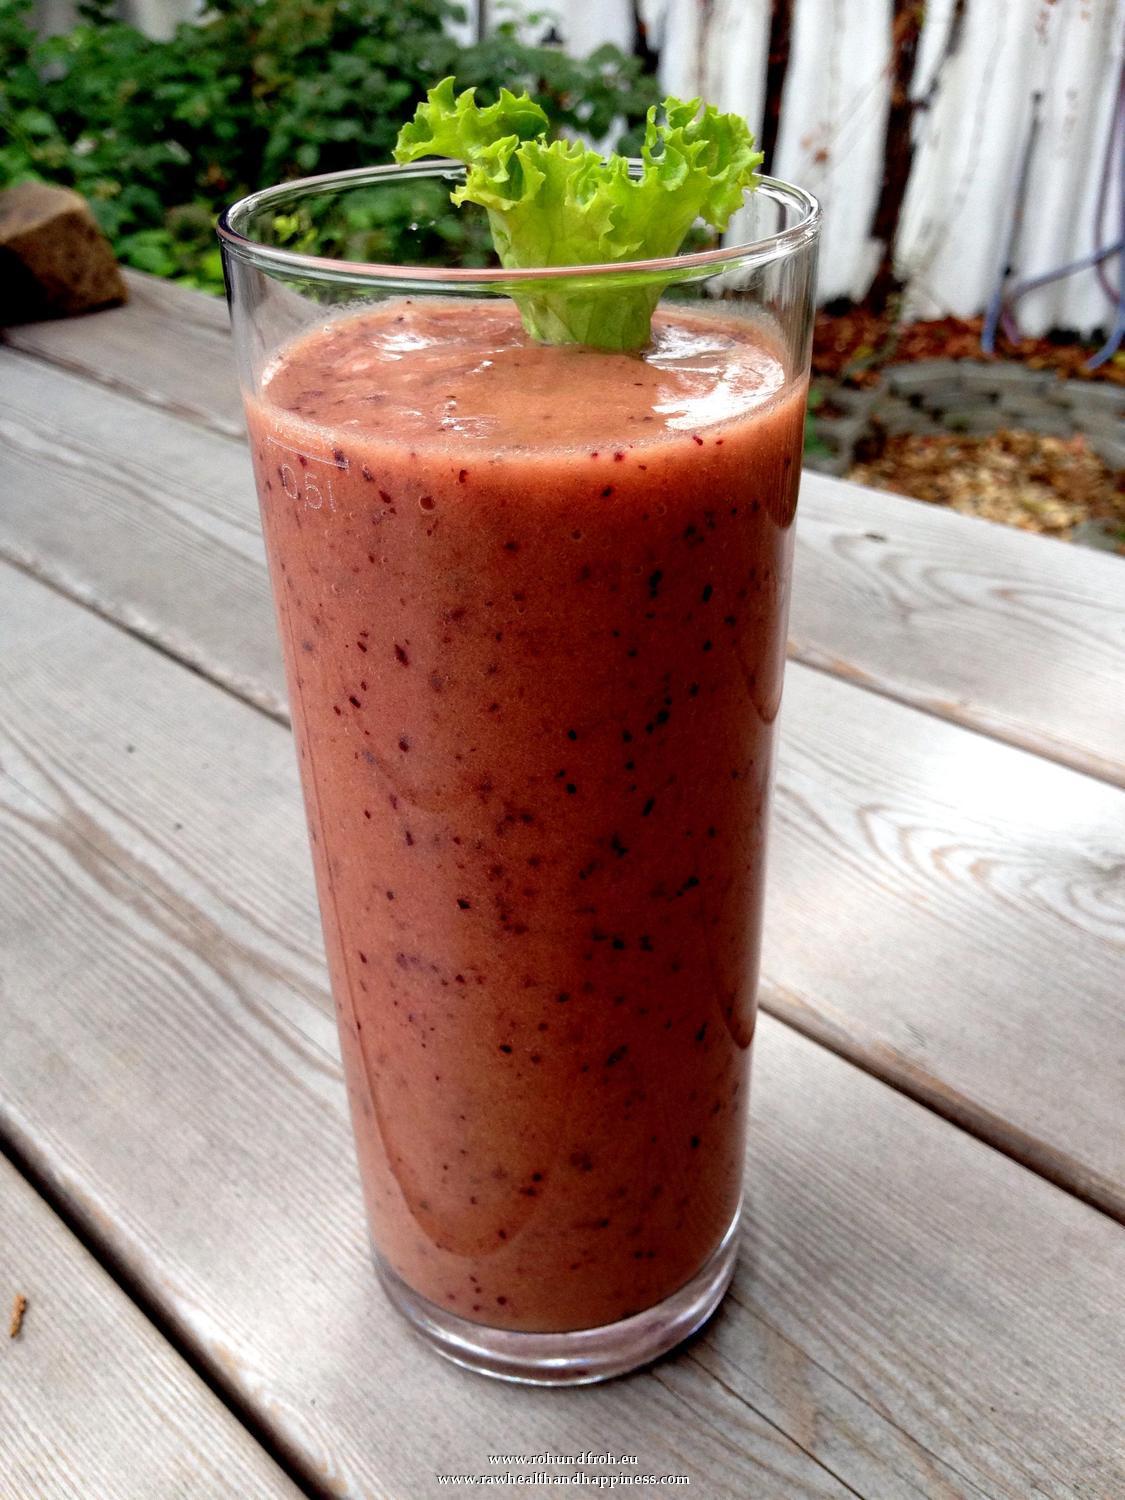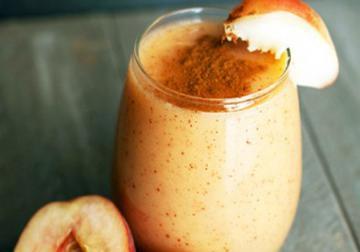The first image is the image on the left, the second image is the image on the right. For the images displayed, is the sentence "There is green juice in one of the images." factually correct? Answer yes or no. No. The first image is the image on the left, the second image is the image on the right. Analyze the images presented: Is the assertion "Each image includes one garnished glass of creamy beverage but no straws, and one of the glasses pictured has a leafy green garnish." valid? Answer yes or no. Yes. 